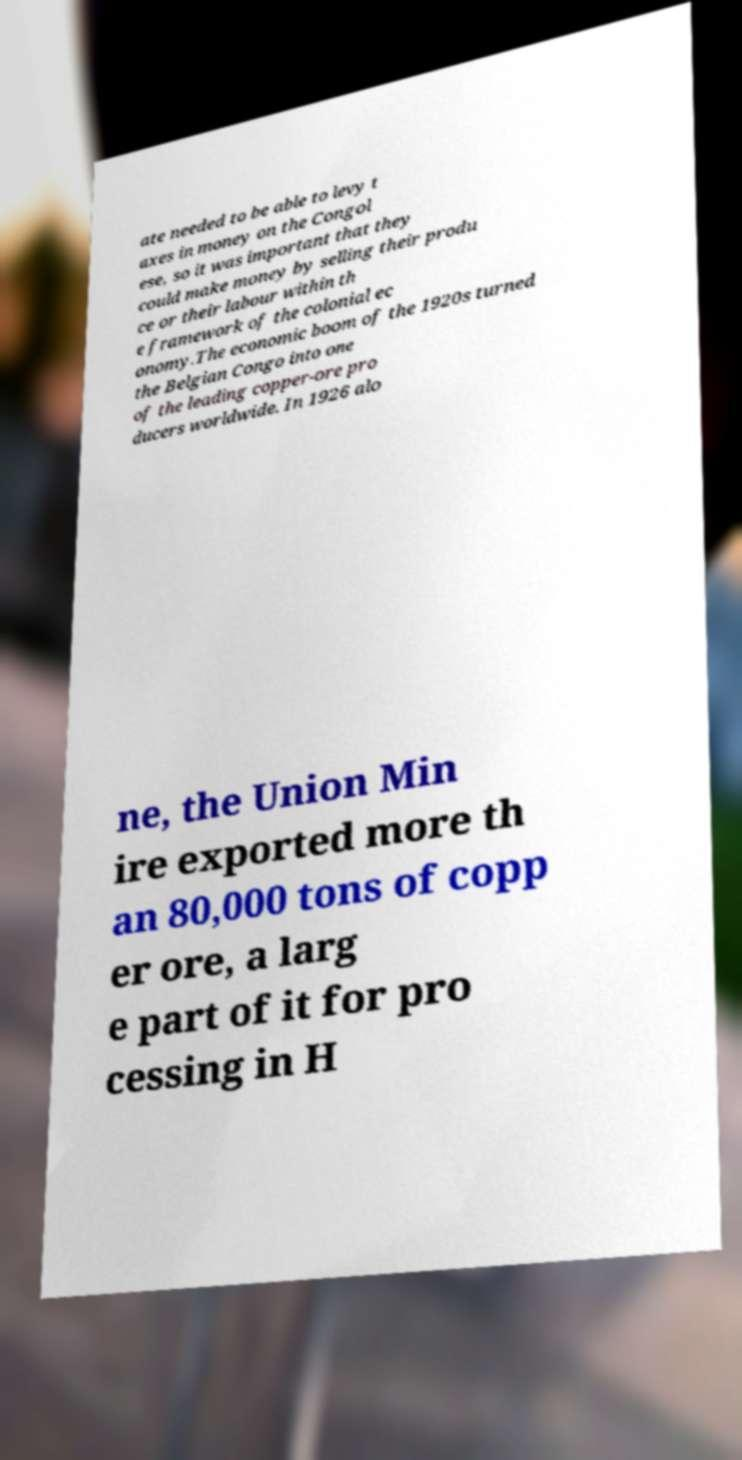Can you accurately transcribe the text from the provided image for me? ate needed to be able to levy t axes in money on the Congol ese, so it was important that they could make money by selling their produ ce or their labour within th e framework of the colonial ec onomy.The economic boom of the 1920s turned the Belgian Congo into one of the leading copper-ore pro ducers worldwide. In 1926 alo ne, the Union Min ire exported more th an 80,000 tons of copp er ore, a larg e part of it for pro cessing in H 